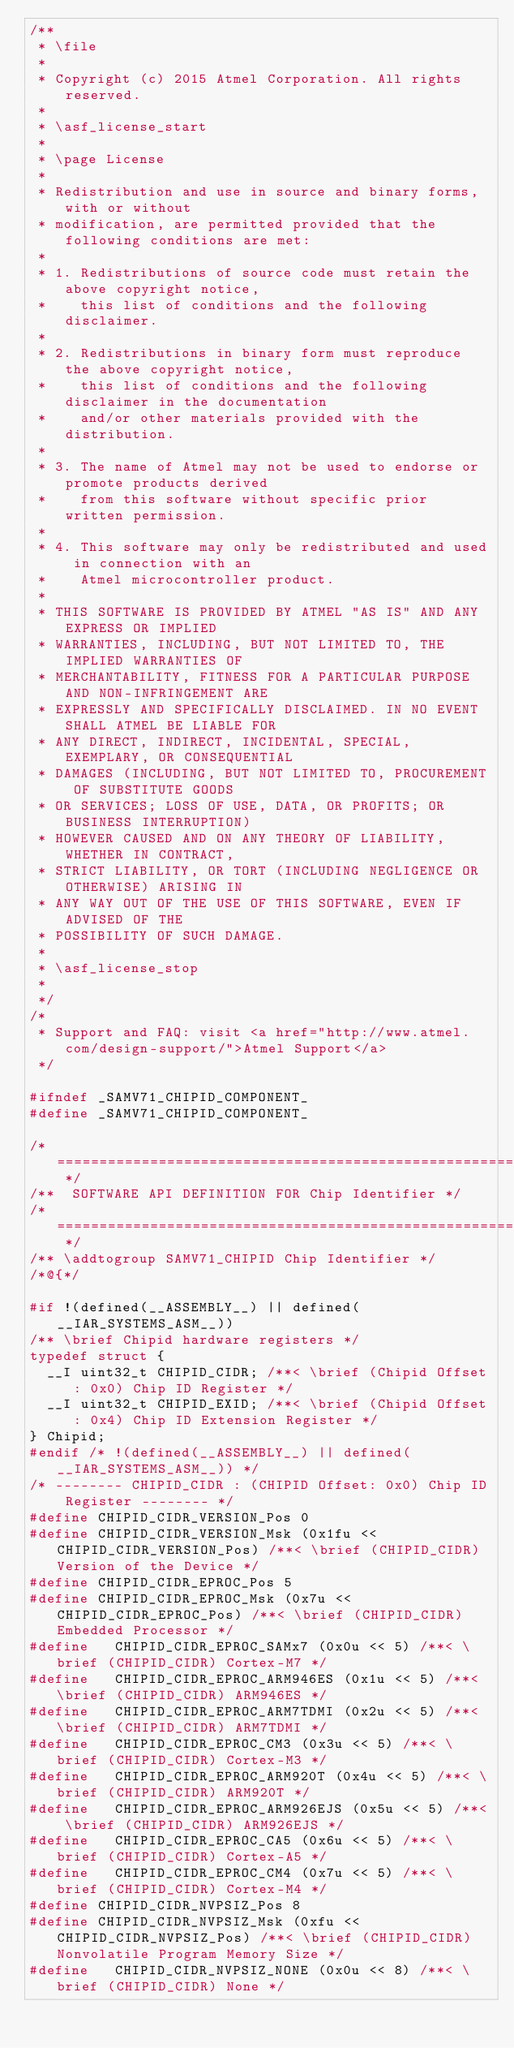<code> <loc_0><loc_0><loc_500><loc_500><_C_>/**
 * \file
 *
 * Copyright (c) 2015 Atmel Corporation. All rights reserved.
 *
 * \asf_license_start
 *
 * \page License
 *
 * Redistribution and use in source and binary forms, with or without
 * modification, are permitted provided that the following conditions are met:
 *
 * 1. Redistributions of source code must retain the above copyright notice,
 *    this list of conditions and the following disclaimer.
 *
 * 2. Redistributions in binary form must reproduce the above copyright notice,
 *    this list of conditions and the following disclaimer in the documentation
 *    and/or other materials provided with the distribution.
 *
 * 3. The name of Atmel may not be used to endorse or promote products derived
 *    from this software without specific prior written permission.
 *
 * 4. This software may only be redistributed and used in connection with an
 *    Atmel microcontroller product.
 *
 * THIS SOFTWARE IS PROVIDED BY ATMEL "AS IS" AND ANY EXPRESS OR IMPLIED
 * WARRANTIES, INCLUDING, BUT NOT LIMITED TO, THE IMPLIED WARRANTIES OF
 * MERCHANTABILITY, FITNESS FOR A PARTICULAR PURPOSE AND NON-INFRINGEMENT ARE
 * EXPRESSLY AND SPECIFICALLY DISCLAIMED. IN NO EVENT SHALL ATMEL BE LIABLE FOR
 * ANY DIRECT, INDIRECT, INCIDENTAL, SPECIAL, EXEMPLARY, OR CONSEQUENTIAL
 * DAMAGES (INCLUDING, BUT NOT LIMITED TO, PROCUREMENT OF SUBSTITUTE GOODS
 * OR SERVICES; LOSS OF USE, DATA, OR PROFITS; OR BUSINESS INTERRUPTION)
 * HOWEVER CAUSED AND ON ANY THEORY OF LIABILITY, WHETHER IN CONTRACT,
 * STRICT LIABILITY, OR TORT (INCLUDING NEGLIGENCE OR OTHERWISE) ARISING IN
 * ANY WAY OUT OF THE USE OF THIS SOFTWARE, EVEN IF ADVISED OF THE
 * POSSIBILITY OF SUCH DAMAGE.
 *
 * \asf_license_stop
 *
 */
/*
 * Support and FAQ: visit <a href="http://www.atmel.com/design-support/">Atmel Support</a>
 */

#ifndef _SAMV71_CHIPID_COMPONENT_
#define _SAMV71_CHIPID_COMPONENT_

/* ============================================================================= */
/**  SOFTWARE API DEFINITION FOR Chip Identifier */
/* ============================================================================= */
/** \addtogroup SAMV71_CHIPID Chip Identifier */
/*@{*/

#if !(defined(__ASSEMBLY__) || defined(__IAR_SYSTEMS_ASM__))
/** \brief Chipid hardware registers */
typedef struct {
  __I uint32_t CHIPID_CIDR; /**< \brief (Chipid Offset: 0x0) Chip ID Register */
  __I uint32_t CHIPID_EXID; /**< \brief (Chipid Offset: 0x4) Chip ID Extension Register */
} Chipid;
#endif /* !(defined(__ASSEMBLY__) || defined(__IAR_SYSTEMS_ASM__)) */
/* -------- CHIPID_CIDR : (CHIPID Offset: 0x0) Chip ID Register -------- */
#define CHIPID_CIDR_VERSION_Pos 0
#define CHIPID_CIDR_VERSION_Msk (0x1fu << CHIPID_CIDR_VERSION_Pos) /**< \brief (CHIPID_CIDR) Version of the Device */
#define CHIPID_CIDR_EPROC_Pos 5
#define CHIPID_CIDR_EPROC_Msk (0x7u << CHIPID_CIDR_EPROC_Pos) /**< \brief (CHIPID_CIDR) Embedded Processor */
#define   CHIPID_CIDR_EPROC_SAMx7 (0x0u << 5) /**< \brief (CHIPID_CIDR) Cortex-M7 */
#define   CHIPID_CIDR_EPROC_ARM946ES (0x1u << 5) /**< \brief (CHIPID_CIDR) ARM946ES */
#define   CHIPID_CIDR_EPROC_ARM7TDMI (0x2u << 5) /**< \brief (CHIPID_CIDR) ARM7TDMI */
#define   CHIPID_CIDR_EPROC_CM3 (0x3u << 5) /**< \brief (CHIPID_CIDR) Cortex-M3 */
#define   CHIPID_CIDR_EPROC_ARM920T (0x4u << 5) /**< \brief (CHIPID_CIDR) ARM920T */
#define   CHIPID_CIDR_EPROC_ARM926EJS (0x5u << 5) /**< \brief (CHIPID_CIDR) ARM926EJS */
#define   CHIPID_CIDR_EPROC_CA5 (0x6u << 5) /**< \brief (CHIPID_CIDR) Cortex-A5 */
#define   CHIPID_CIDR_EPROC_CM4 (0x7u << 5) /**< \brief (CHIPID_CIDR) Cortex-M4 */
#define CHIPID_CIDR_NVPSIZ_Pos 8
#define CHIPID_CIDR_NVPSIZ_Msk (0xfu << CHIPID_CIDR_NVPSIZ_Pos) /**< \brief (CHIPID_CIDR) Nonvolatile Program Memory Size */
#define   CHIPID_CIDR_NVPSIZ_NONE (0x0u << 8) /**< \brief (CHIPID_CIDR) None */</code> 